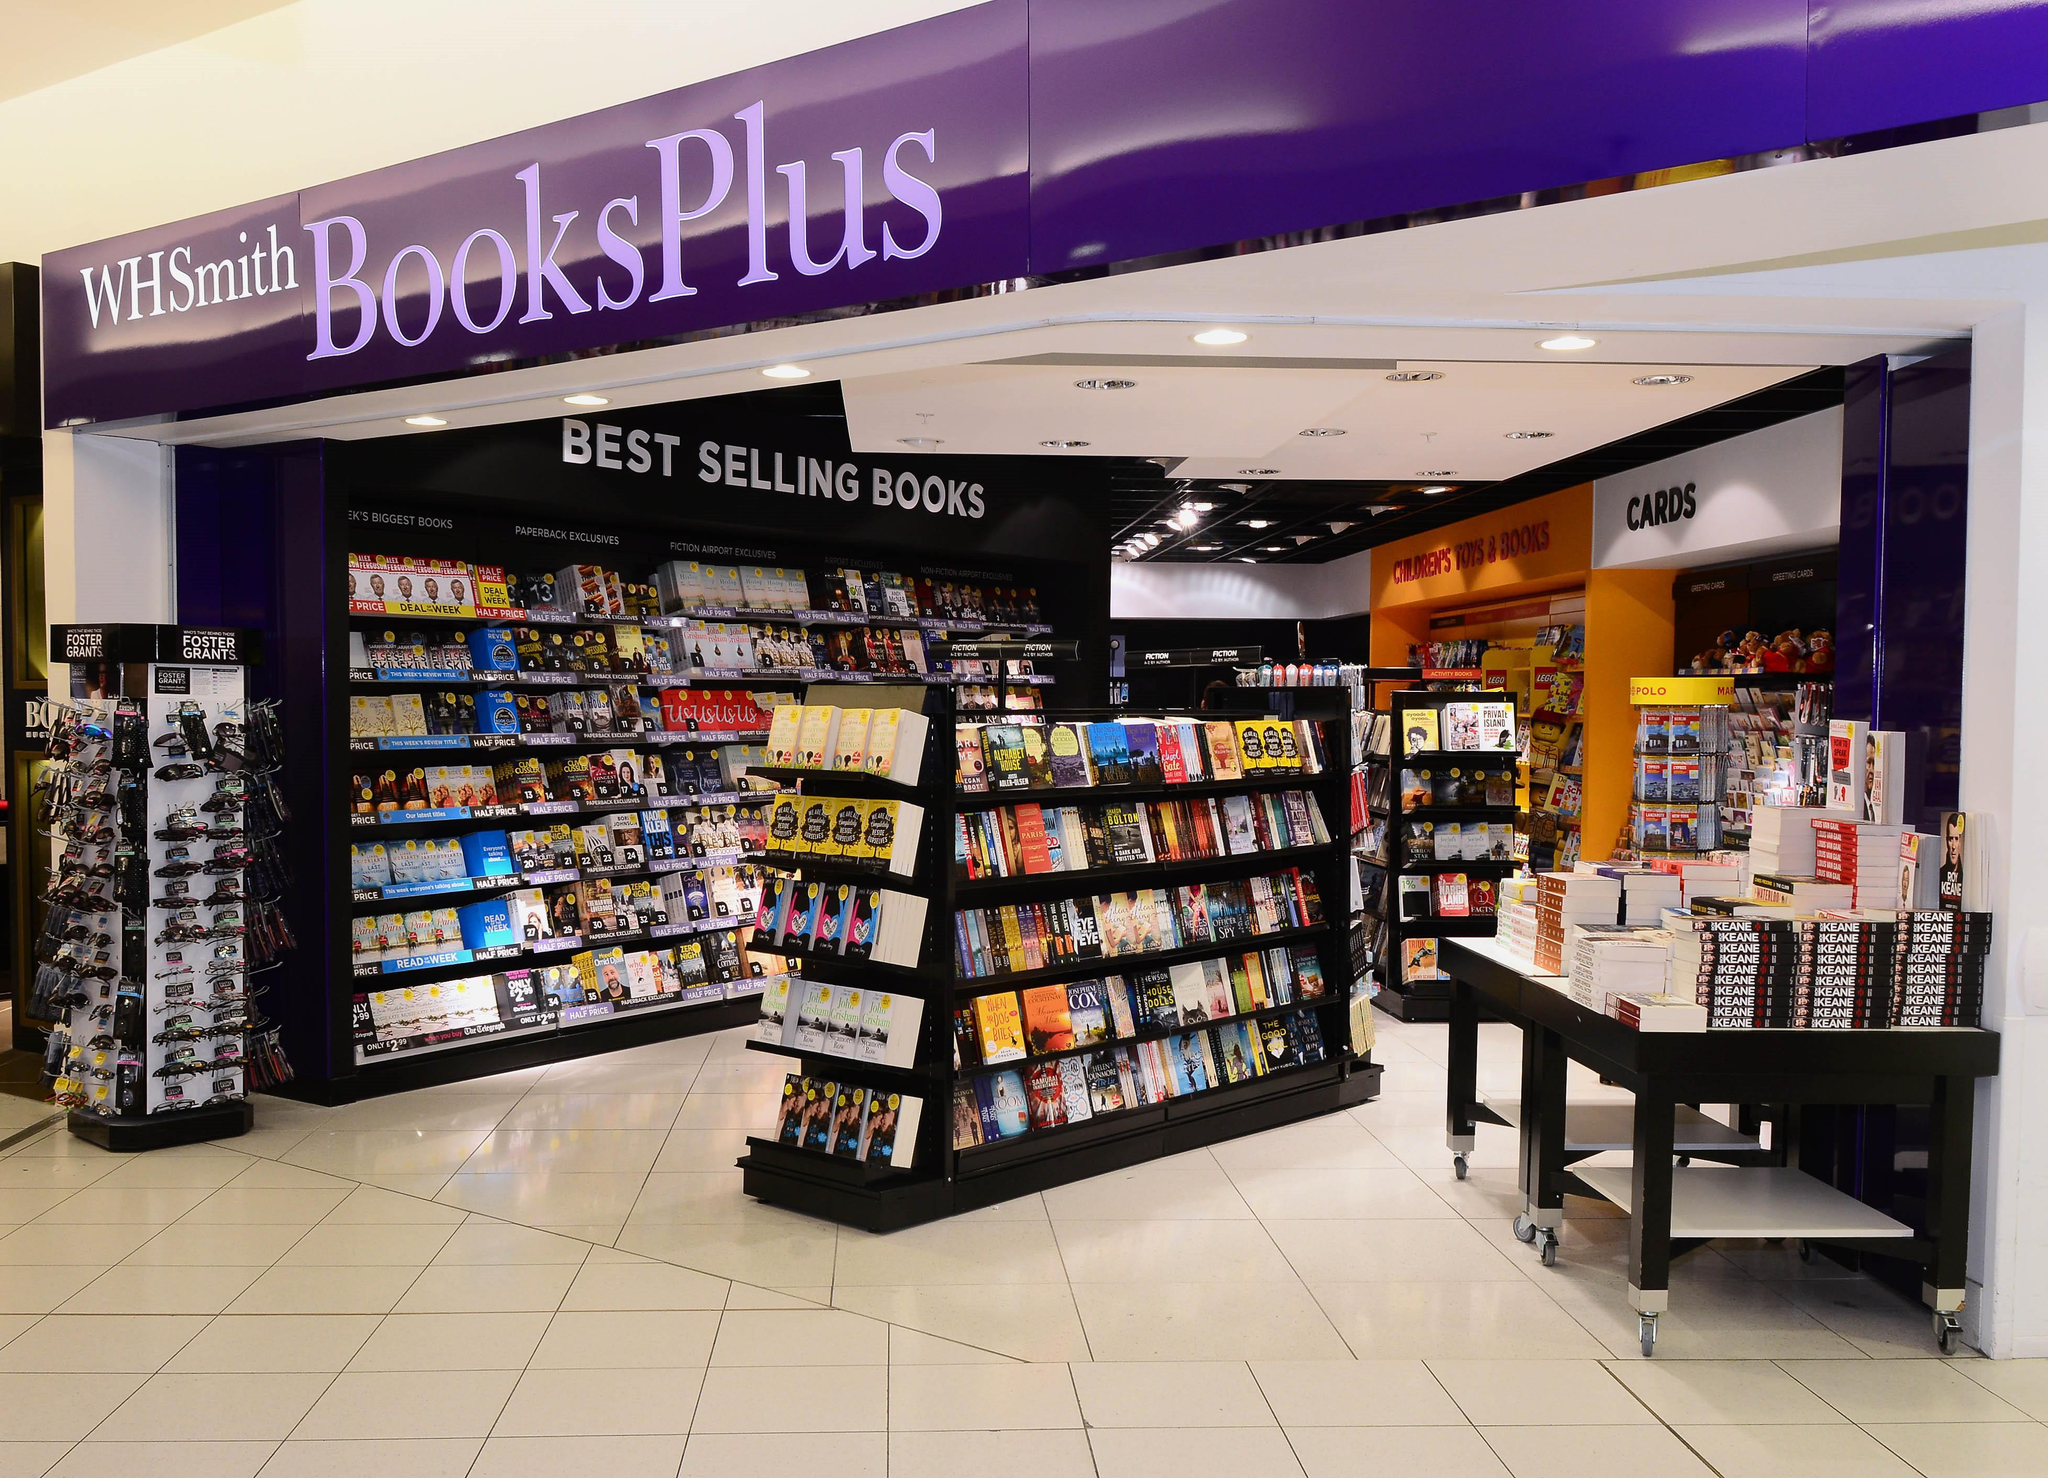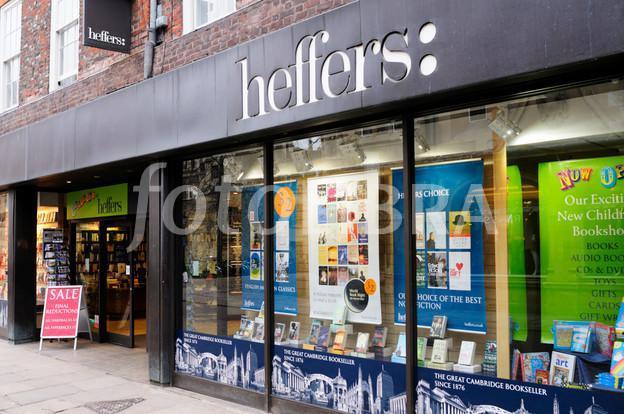The first image is the image on the left, the second image is the image on the right. Analyze the images presented: Is the assertion "Both images show store exteriors with red-background signs above the entrance." valid? Answer yes or no. No. The first image is the image on the left, the second image is the image on the right. Analyze the images presented: Is the assertion "In one image, a clerk can be seen to the left behind a counter of a bookstore, bookshelves extending down that wall and across the back, with three customers in the store." valid? Answer yes or no. No. 